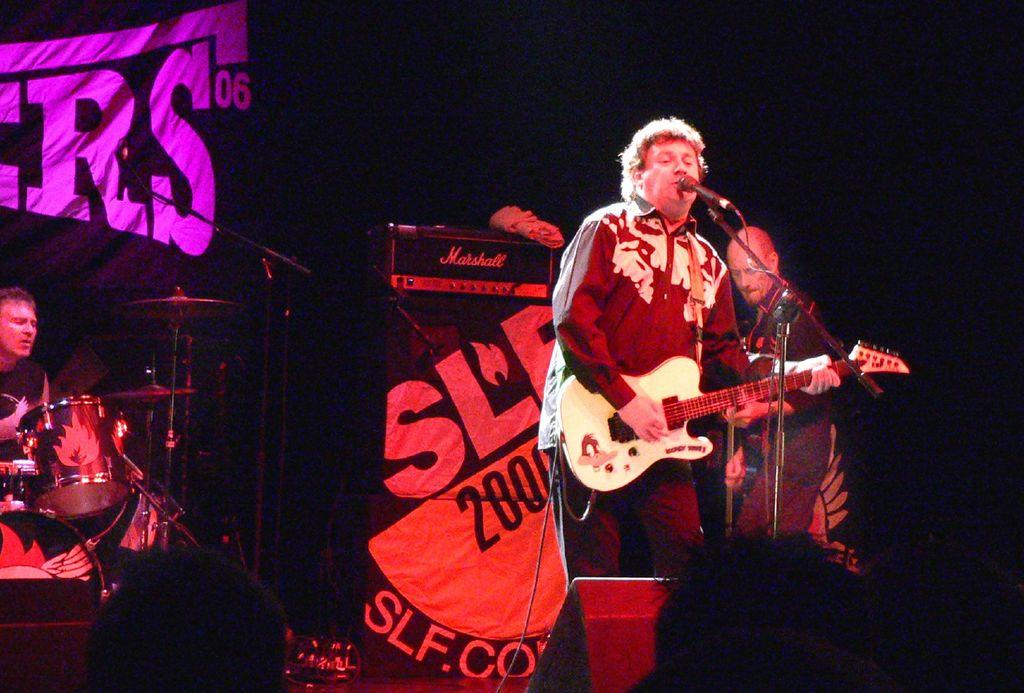What is the color of the background in the image? The background of the image is dark. What are the two persons in the image doing? The two persons are standing in front of a microphone and playing guitars. What is the third person in the image doing? There is a man sitting and playing drums. What type of detail can be seen on the ground in the image? There is no ground visible in the image, as it appears to be a studio or stage setting. What type of thing is the man playing drums with? The man is playing drums with drumsticks, which are not explicitly visible in the image but are typically used for playing drums. 